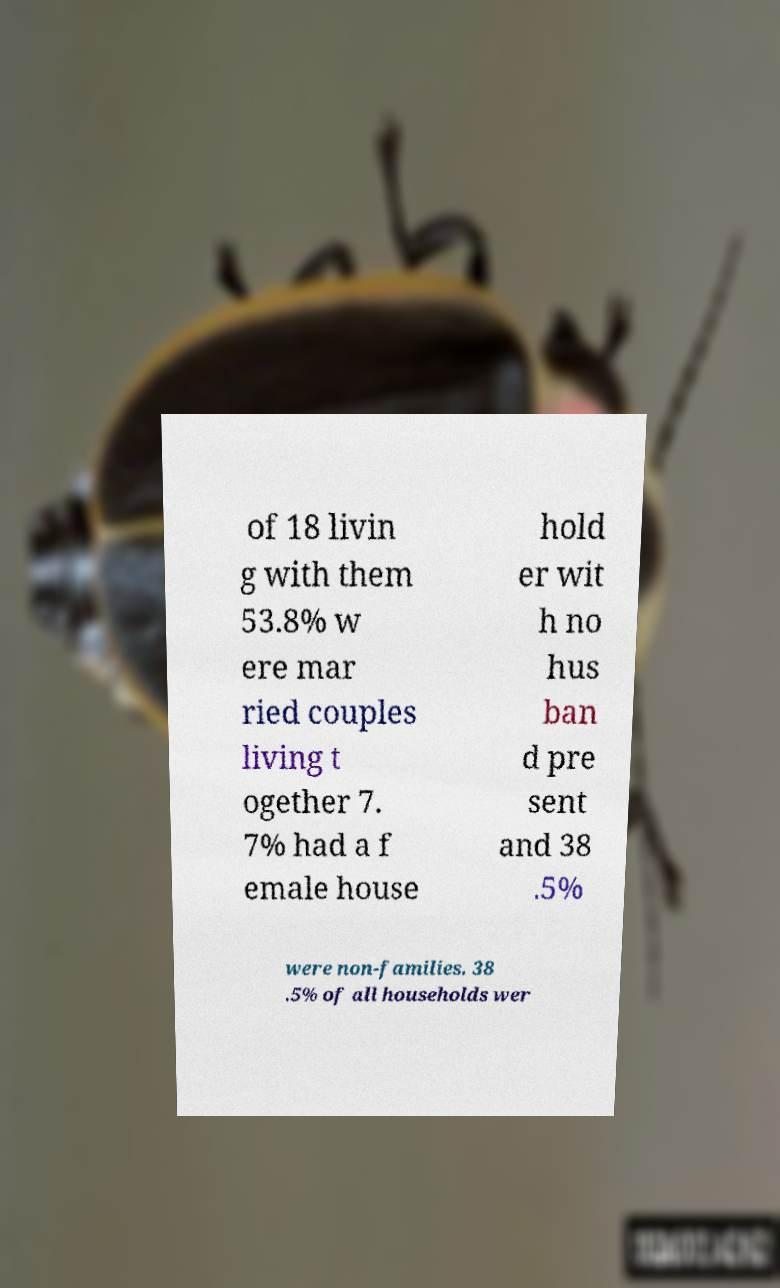Could you extract and type out the text from this image? of 18 livin g with them 53.8% w ere mar ried couples living t ogether 7. 7% had a f emale house hold er wit h no hus ban d pre sent and 38 .5% were non-families. 38 .5% of all households wer 